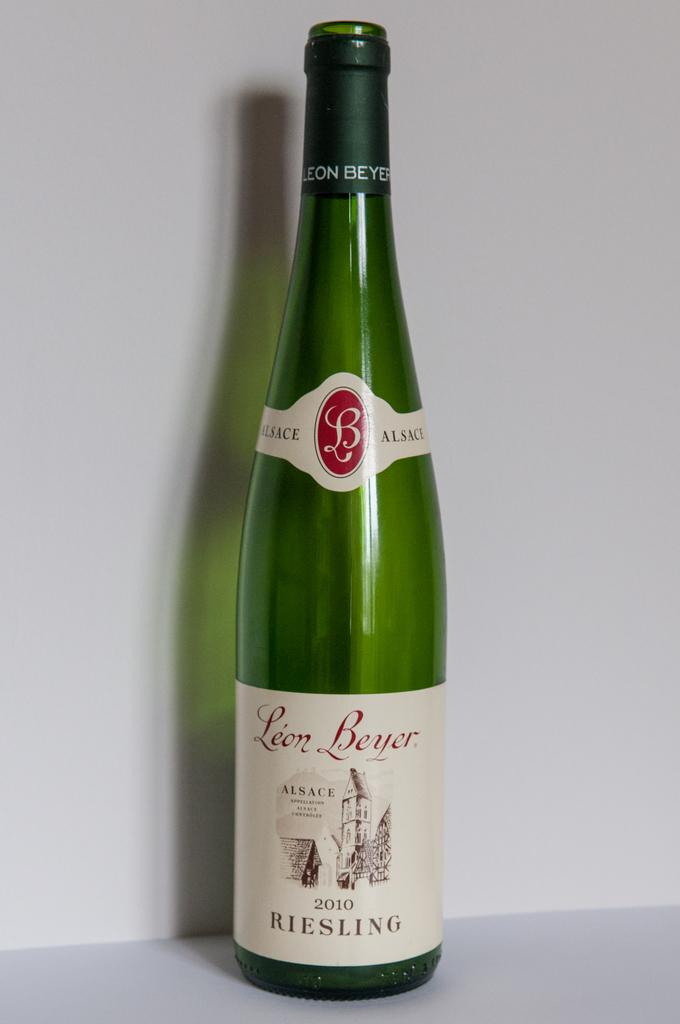<image>
Render a clear and concise summary of the photo. The bottle of white Riesling wine was created in 2010. 